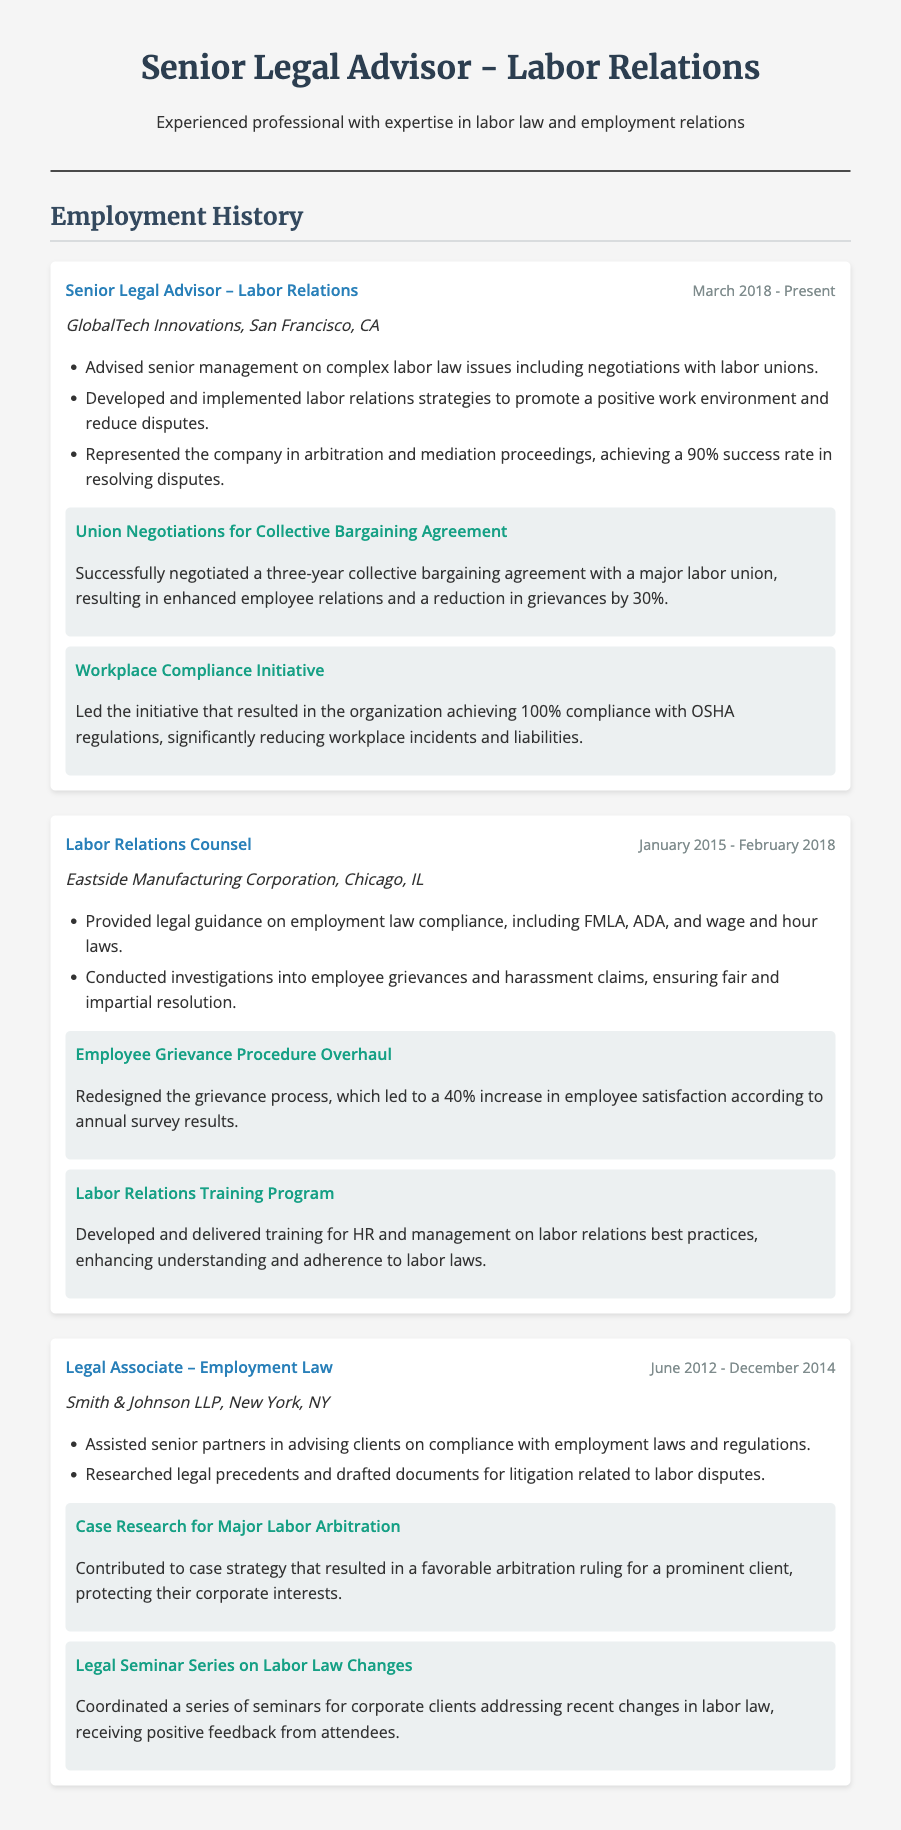What is the current job title of the individual? The individual's current job title is stated at the top of the employment history section, which is "Senior Legal Advisor – Labor Relations."
Answer: Senior Legal Advisor – Labor Relations In which city does the individual currently work? The individual's current workplace is mentioned along with the company name, located in San Francisco, CA.
Answer: San Francisco, CA What percentage of success did the individual achieve in arbitration and mediation proceedings? The document states that the individual achieved a 90% success rate in arbitration and mediation proceedings.
Answer: 90% What was the outcome of the collective bargaining agreement negotiation? The successful negotiation is noted to have resulted in enhanced employee relations and a reduction in grievances.
Answer: Reduction in grievances by 30% How many years did the individual serve as Labor Relations Counsel? The time period for this role is provided as from January 2015 to February 2018, which is approximately 3 years.
Answer: 3 years What was one effect of the redesigned grievance process at Eastside Manufacturing Corporation? The document states that there was a 40% increase in employee satisfaction following the redesign of the grievance process.
Answer: 40% increase in employee satisfaction Which regulations did the individual ensure compliance with during the Workplace Compliance Initiative? The initiative resulted in the organization achieving compliance with OSHA regulations.
Answer: OSHA regulations How was the labor relations training program received? The document does not detail exact feedback but indicates the training enhanced understanding and adherence to labor laws, implying a positive reception.
Answer: Enhanced understanding of labor laws 